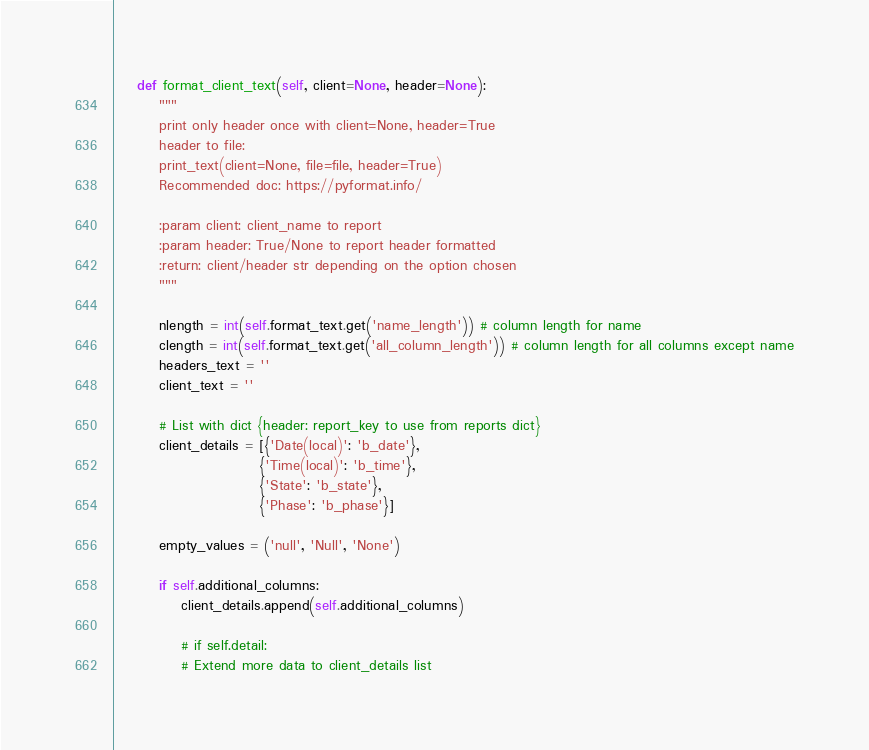Convert code to text. <code><loc_0><loc_0><loc_500><loc_500><_Python_>
    def format_client_text(self, client=None, header=None):
        """
        print only header once with client=None, header=True
        header to file:
        print_text(client=None, file=file, header=True)
        Recommended doc: https://pyformat.info/

        :param client: client_name to report
        :param header: True/None to report header formatted
        :return: client/header str depending on the option chosen
        """

        nlength = int(self.format_text.get('name_length')) # column length for name
        clength = int(self.format_text.get('all_column_length')) # column length for all columns except name
        headers_text = ''
        client_text = ''

        # List with dict {header: report_key to use from reports dict}
        client_details = [{'Date(local)': 'b_date'},
                          {'Time(local)': 'b_time'},
                          {'State': 'b_state'},
                          {'Phase': 'b_phase'}]

        empty_values = ('null', 'Null', 'None')

        if self.additional_columns:
            client_details.append(self.additional_columns)

            # if self.detail:
            # Extend more data to client_details list</code> 